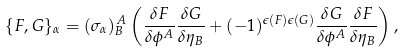Convert formula to latex. <formula><loc_0><loc_0><loc_500><loc_500>\{ F , G \} _ { \alpha } = ( \sigma _ { \alpha } ) _ { B } ^ { \, A } \left ( \frac { \delta F } { \delta \phi ^ { A } } \frac { \delta G } { \delta \eta _ { B } } + ( - 1 ) ^ { \epsilon ( F ) \epsilon ( G ) } \frac { \delta G } { \delta \phi ^ { A } } \frac { \delta F } { \delta \eta _ { B } } \right ) ,</formula> 